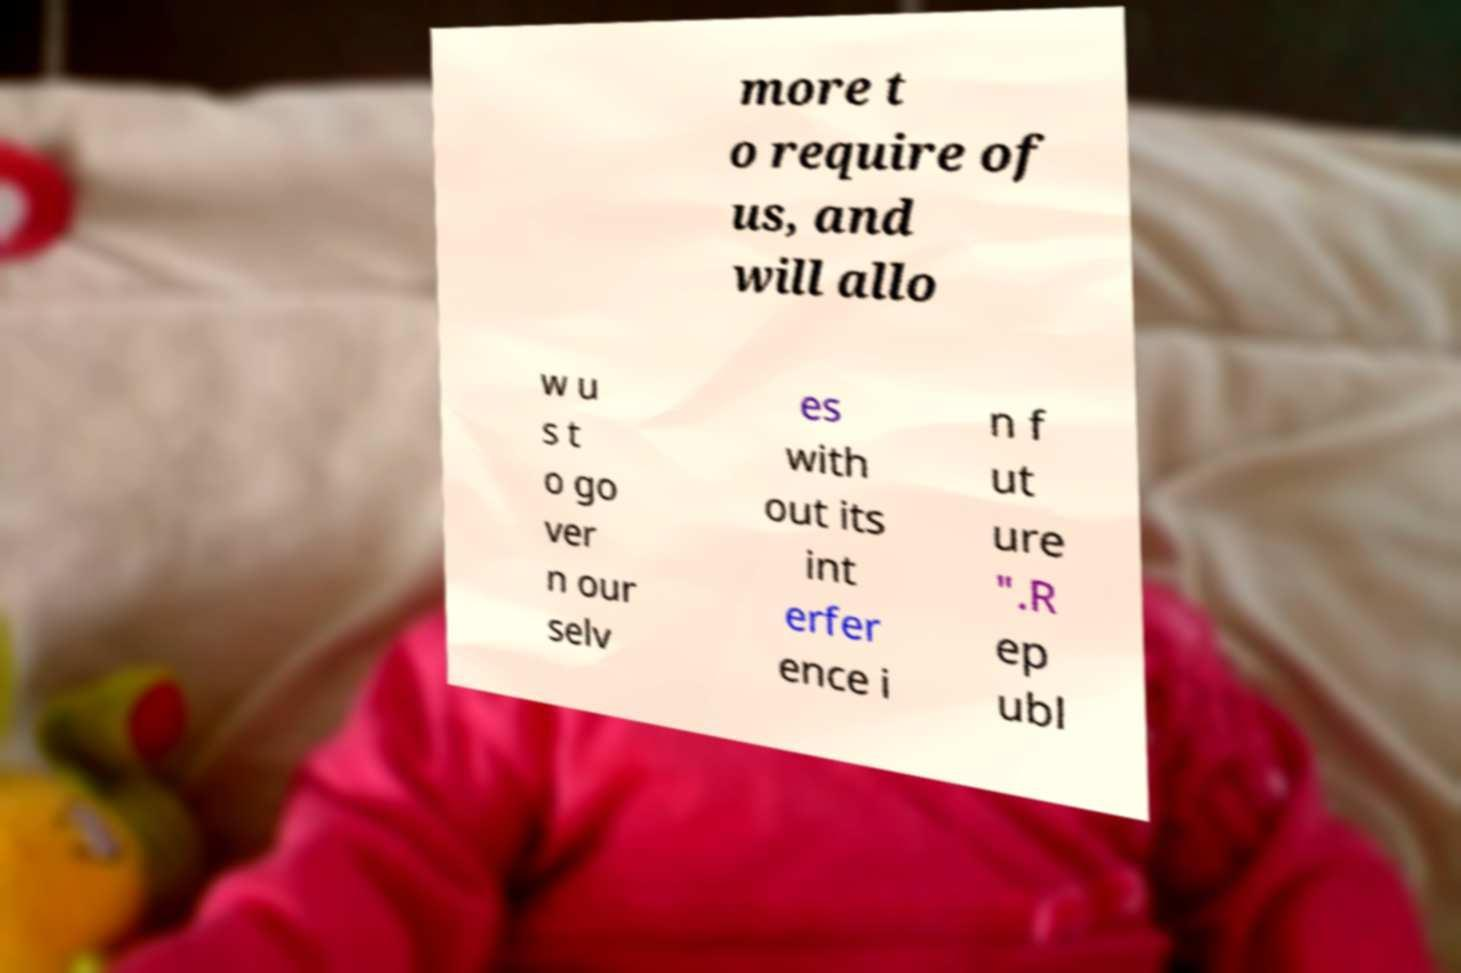Could you assist in decoding the text presented in this image and type it out clearly? more t o require of us, and will allo w u s t o go ver n our selv es with out its int erfer ence i n f ut ure ".R ep ubl 